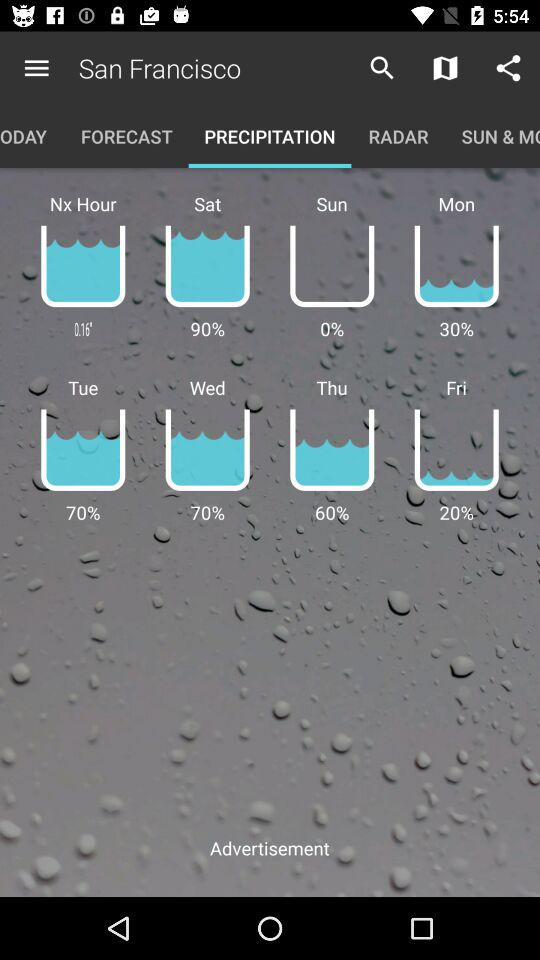What is the highest percentage of precipitation?
Answer the question using a single word or phrase. 90% 